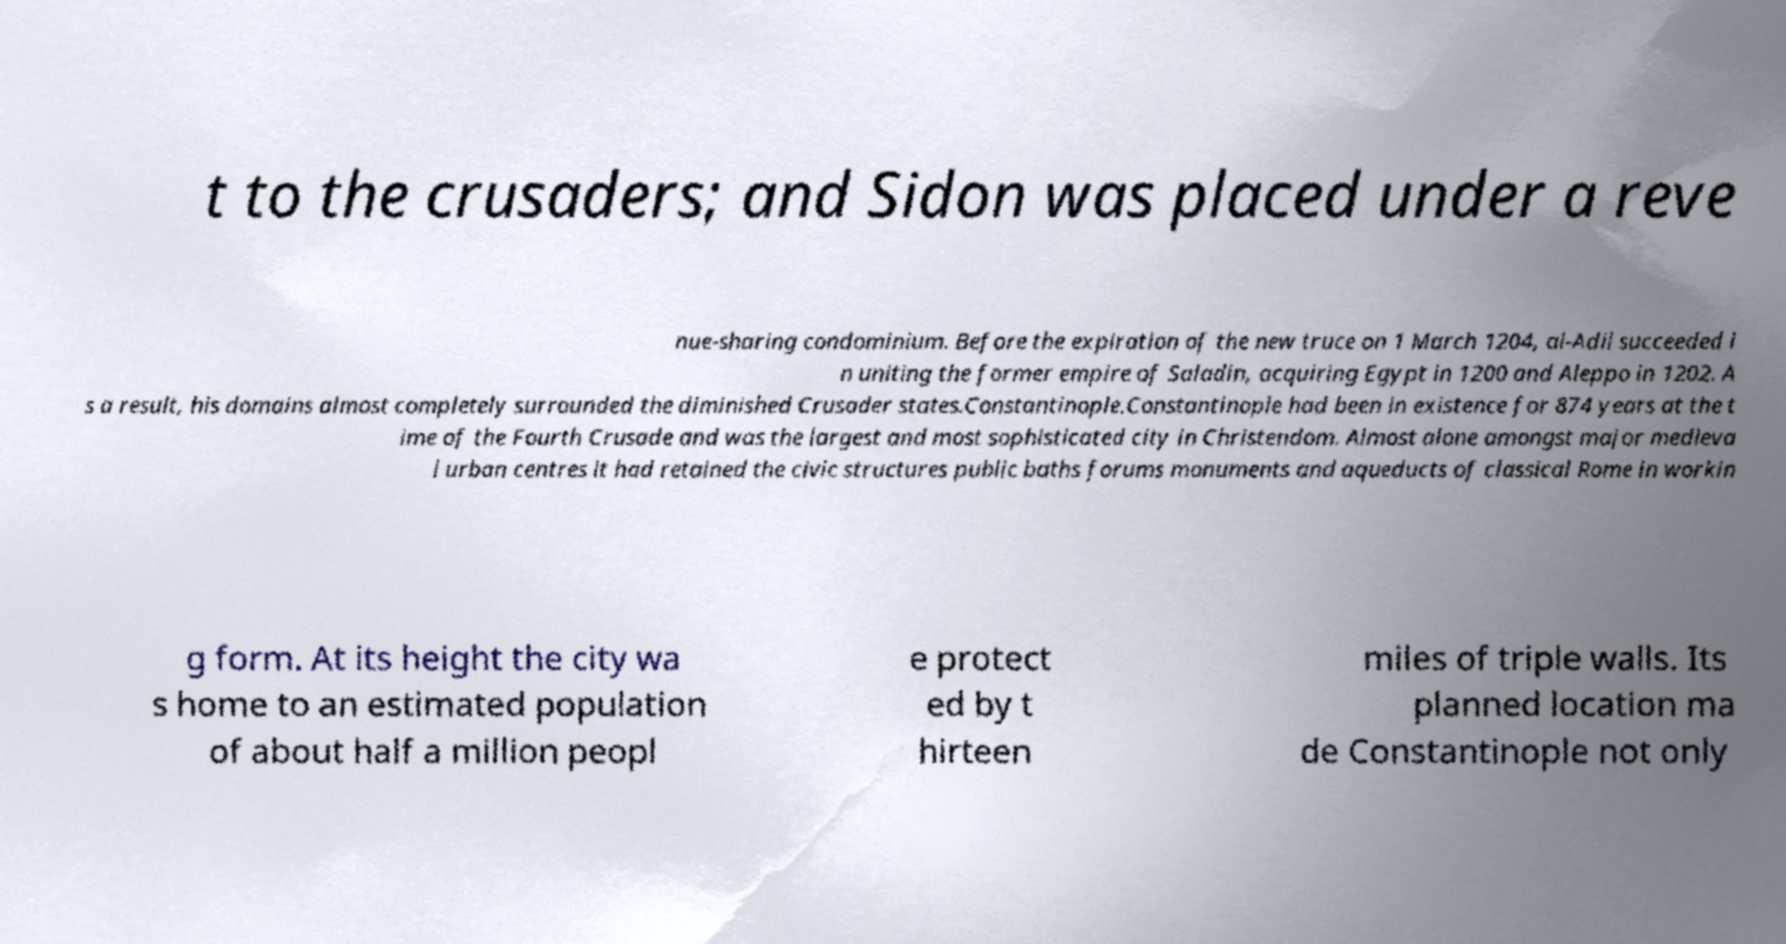Can you read and provide the text displayed in the image?This photo seems to have some interesting text. Can you extract and type it out for me? t to the crusaders; and Sidon was placed under a reve nue-sharing condominium. Before the expiration of the new truce on 1 March 1204, al-Adil succeeded i n uniting the former empire of Saladin, acquiring Egypt in 1200 and Aleppo in 1202. A s a result, his domains almost completely surrounded the diminished Crusader states.Constantinople.Constantinople had been in existence for 874 years at the t ime of the Fourth Crusade and was the largest and most sophisticated city in Christendom. Almost alone amongst major medieva l urban centres it had retained the civic structures public baths forums monuments and aqueducts of classical Rome in workin g form. At its height the city wa s home to an estimated population of about half a million peopl e protect ed by t hirteen miles of triple walls. Its planned location ma de Constantinople not only 